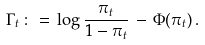<formula> <loc_0><loc_0><loc_500><loc_500>\Gamma _ { t } \, \colon = \, \log \frac { \pi _ { t } } { 1 - \pi _ { t } } \, - \, \Phi ( \pi _ { t } ) \, .</formula> 